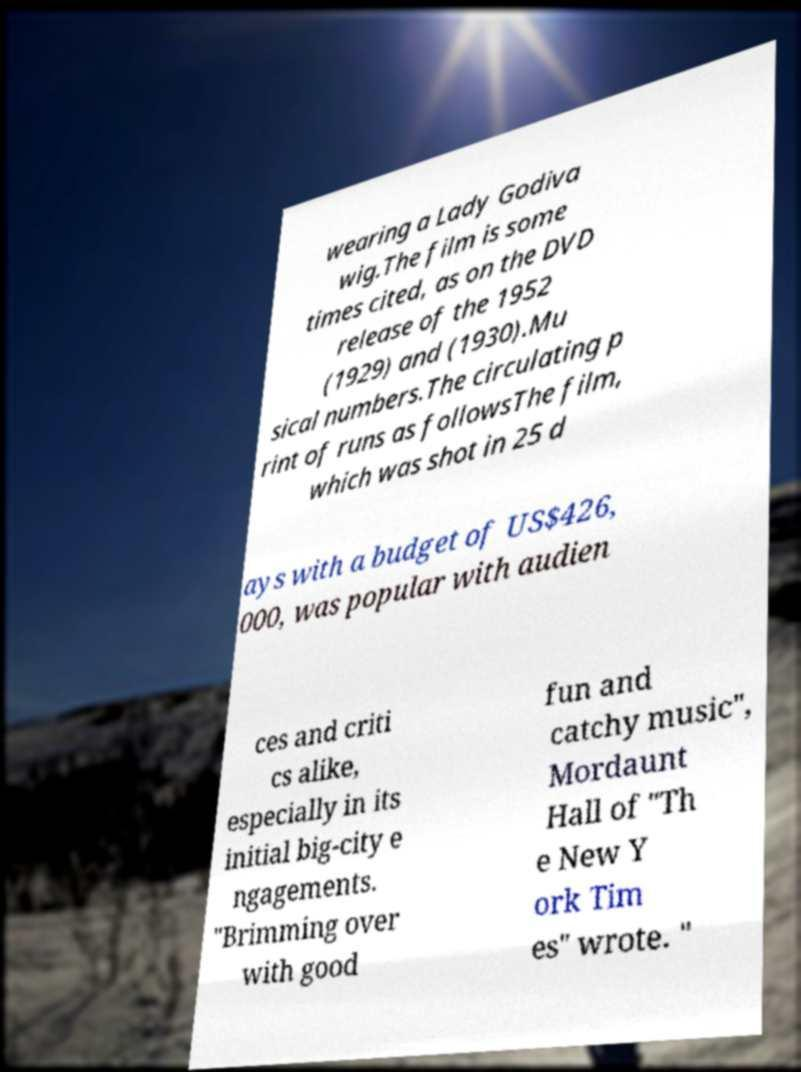Could you extract and type out the text from this image? wearing a Lady Godiva wig.The film is some times cited, as on the DVD release of the 1952 (1929) and (1930).Mu sical numbers.The circulating p rint of runs as followsThe film, which was shot in 25 d ays with a budget of US$426, 000, was popular with audien ces and criti cs alike, especially in its initial big-city e ngagements. "Brimming over with good fun and catchy music", Mordaunt Hall of "Th e New Y ork Tim es" wrote. " 